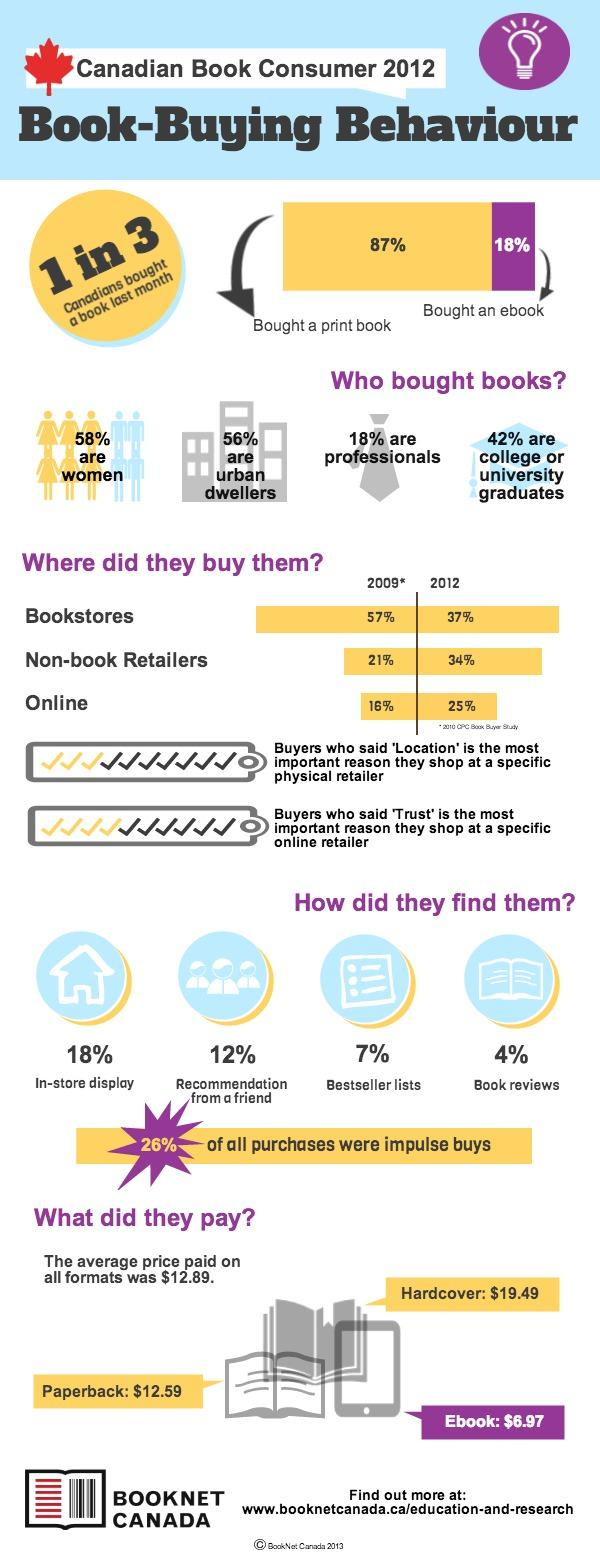Give some essential details in this illustration. Ebook is the book format that costs the least. According to where they live, urban dwellers are the majority of book buyers. 11% of people found books from bestseller lists and book reviews. A significant portion of book buyers, or 42%, are men. The available book formats include paperback, hardcover, and ebook, each with their unique characteristics and purposes. 